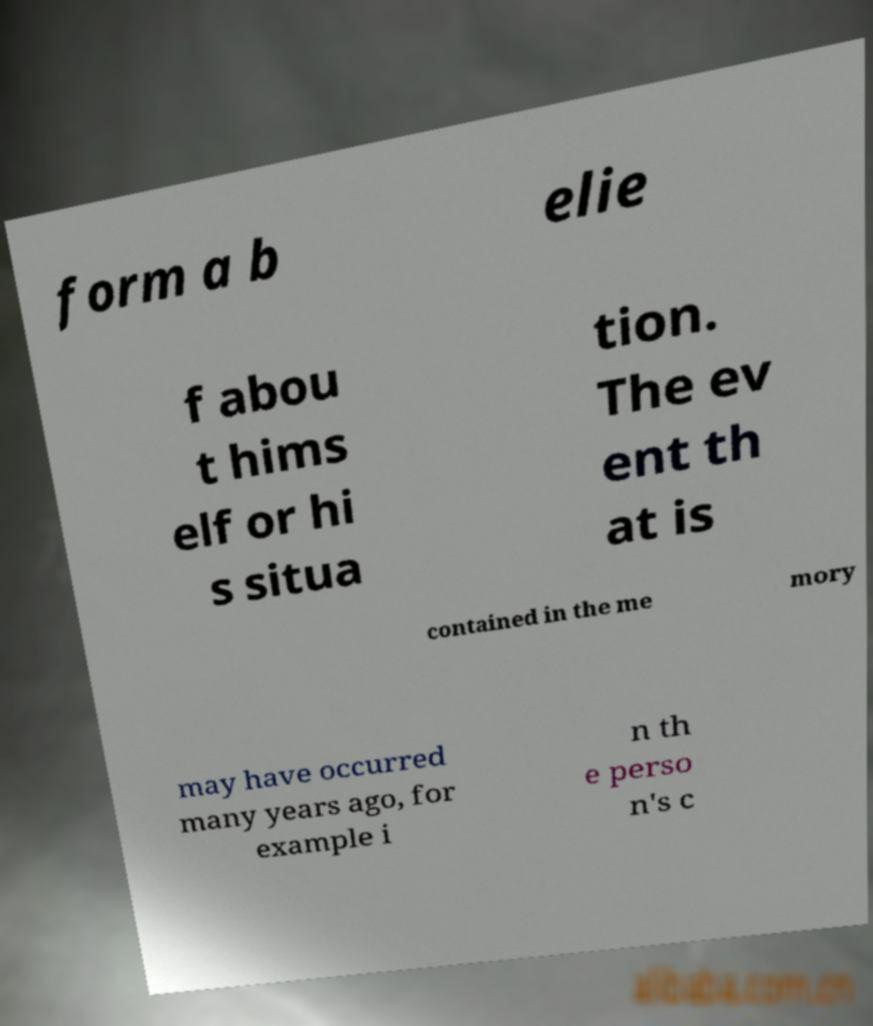Can you read and provide the text displayed in the image?This photo seems to have some interesting text. Can you extract and type it out for me? form a b elie f abou t hims elf or hi s situa tion. The ev ent th at is contained in the me mory may have occurred many years ago, for example i n th e perso n's c 